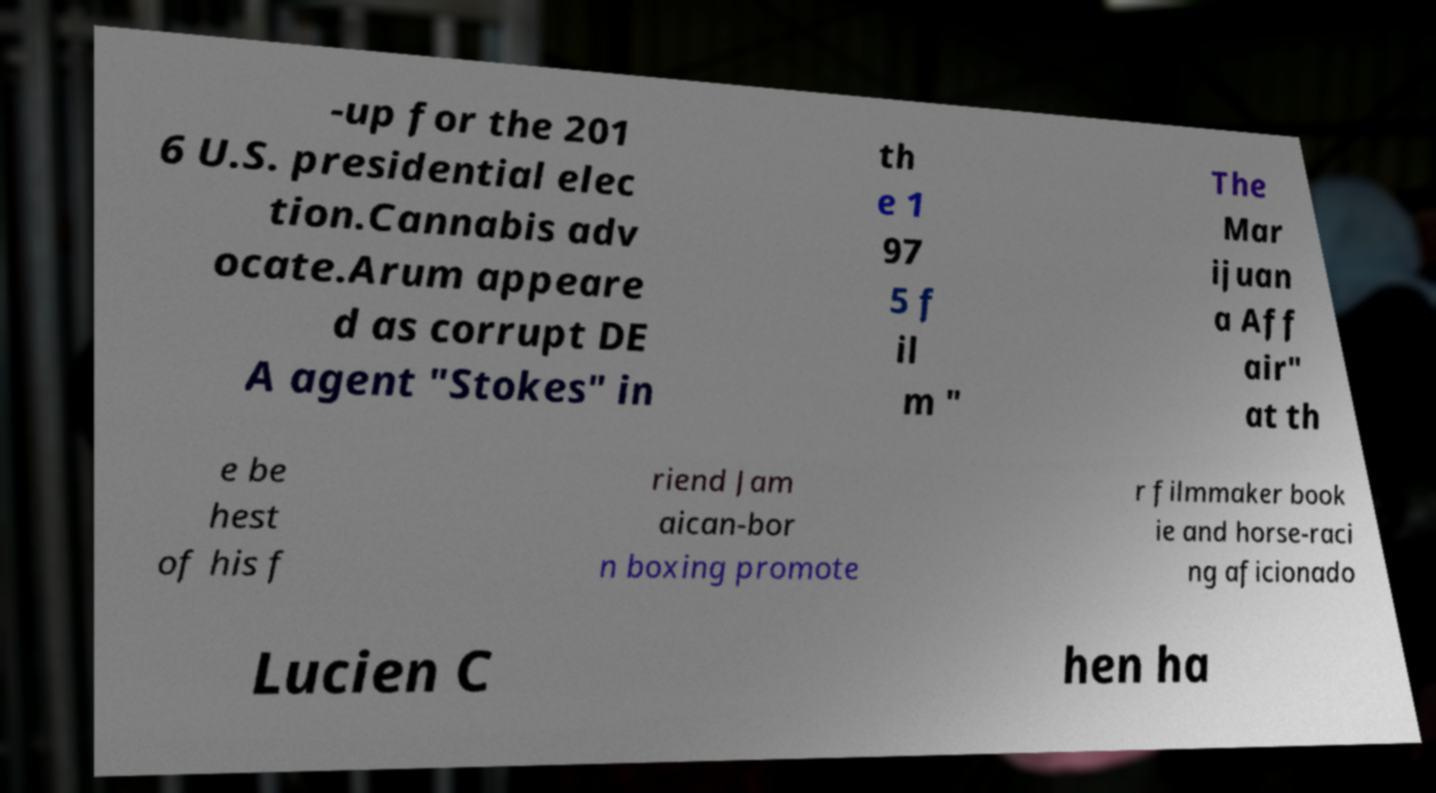Could you assist in decoding the text presented in this image and type it out clearly? -up for the 201 6 U.S. presidential elec tion.Cannabis adv ocate.Arum appeare d as corrupt DE A agent "Stokes" in th e 1 97 5 f il m " The Mar ijuan a Aff air" at th e be hest of his f riend Jam aican-bor n boxing promote r filmmaker book ie and horse-raci ng aficionado Lucien C hen ha 